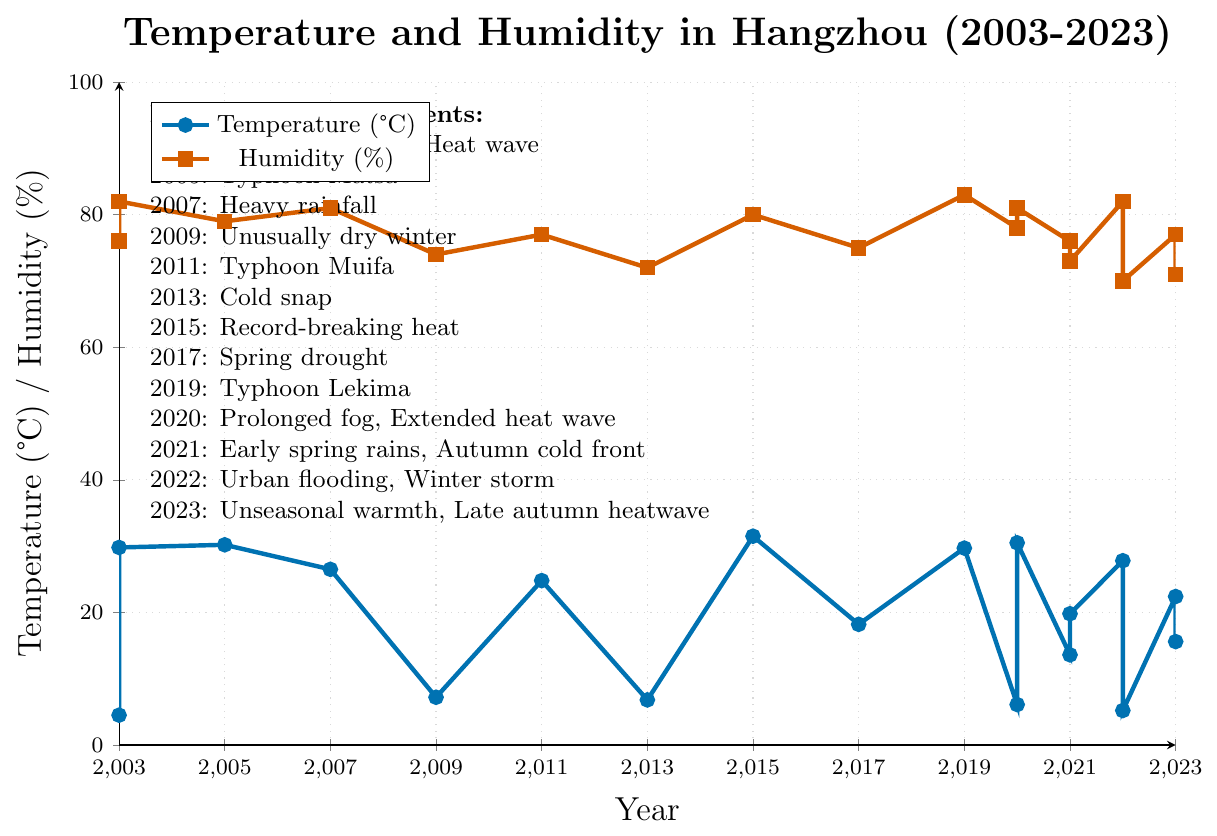What was the highest average temperature recorded, and in which year and month did it occur? The peak temperature can be identified by observing the highest point in the blue line on the chart. According to the data provided, the highest average temperature was recorded in July 2015, marked as record-breaking heat.
Answer: 31.5°C in July 2015 What was the average humidity level during the unusually dry winter in 2009? The humidity level during extreme weather events is marked by red dots. For 2009, the extremely dry winter is marked, and the corresponding humidity level on the red line is 74%.
Answer: 74% Did the year 2023 experience any extreme weather events and if yes, what were they? The extreme weather events are listed in a note on the upper left of the chart. For 2023, two events are listed: unseasonal warmth and a late autumn heatwave.
Answer: Unseasonal warmth, Late autumn heatwave Compare the humidity levels between Typhoon Matsa in August 2005 and Typhoon Lekima in August 2019. Which event had a higher humidity level? By looking at the red squares corresponding to August 2005 and August 2019, we can compare their humidity levels. The coordinates show that August 2005 had a humidity of 79%, whereas August 2019 had a humidity of 83%.
Answer: Typhoon Lekima in August 2019 Calculate the average temperature for the year 2022 combining both months' data, and determine if it's higher or lower than the average temperature in 2020. The 2022 temperature values are June (27.8) and December (5.2). Combine these: (27.8 + 5.2)/2 = 16.5°C. For 2020, January (6.1) and July (30.5), the average is (6.1 + 30.5)/2 = 18.3°C. Comparing the two, 16.5°C in 2022 is lower than 18.3°C in 2020.
Answer: Lower Which year had the highest humidity level recorded and what was the corresponding value? The highest point on the red line corresponds to the highest humidity level. This occurred in August 2019 with a value of 83%.
Answer: 83% in August 2019 Considering the data points for 2021, which season (Spring, Summer, Fall, Winter) experienced a cold front and how is it visually indicated? The chart’s annotation notes an autumn cold front in 2021. This can be visually identified by the relatively lower temperatures in October 2021.
Answer: Autumn Was there a correlation between the heavy rainfall in June 2007 and the average humidity level that month? Observing the data for June 2007, which was marked by heavy rainfall, the corresponding humidity level is 81%. Rain events typically increase humidity; thus, this high humidity correlates with heavy rainfall.
Answer: Yes, high humidity (81%) What are the temperature and humidity trends observed in the months experiencing typhoons? Provide at least two instances. Instance 1: Typhoon Matsa in August 2005 saw temperature (30.2°C) and humidity (79%). Instance 2: Typhoon Lekima in August 2019 had temperature (29.7°C) and humidity (83%). Both instances show high temperatures and humidity.
Answer: High temperatures and humidity (e.g., August 2005 and August 2019) 